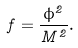<formula> <loc_0><loc_0><loc_500><loc_500>f = \frac { \phi ^ { 2 } } { M ^ { 2 } } .</formula> 